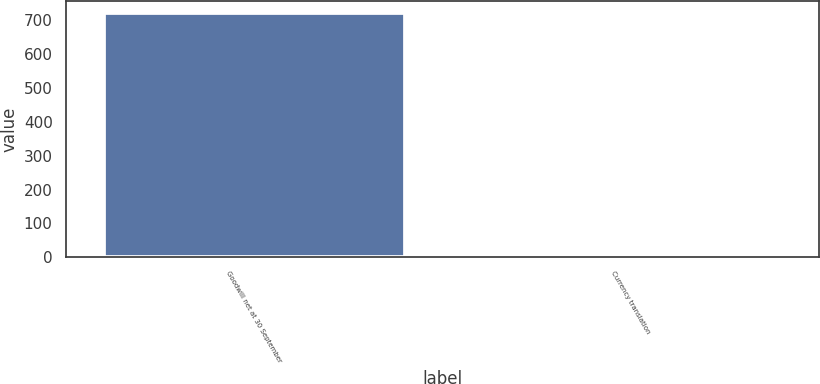<chart> <loc_0><loc_0><loc_500><loc_500><bar_chart><fcel>Goodwill net at 30 September<fcel>Currency translation<nl><fcel>721.5<fcel>8<nl></chart> 